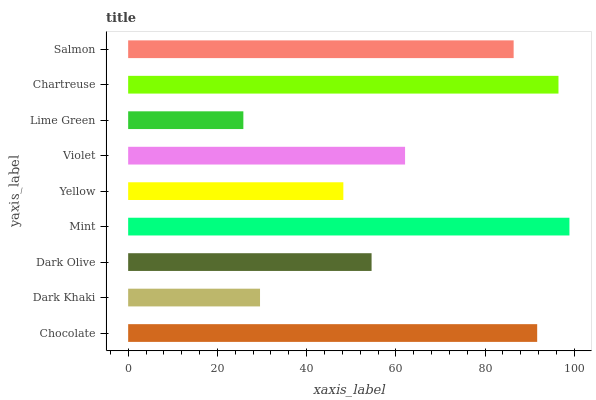Is Lime Green the minimum?
Answer yes or no. Yes. Is Mint the maximum?
Answer yes or no. Yes. Is Dark Khaki the minimum?
Answer yes or no. No. Is Dark Khaki the maximum?
Answer yes or no. No. Is Chocolate greater than Dark Khaki?
Answer yes or no. Yes. Is Dark Khaki less than Chocolate?
Answer yes or no. Yes. Is Dark Khaki greater than Chocolate?
Answer yes or no. No. Is Chocolate less than Dark Khaki?
Answer yes or no. No. Is Violet the high median?
Answer yes or no. Yes. Is Violet the low median?
Answer yes or no. Yes. Is Lime Green the high median?
Answer yes or no. No. Is Dark Olive the low median?
Answer yes or no. No. 